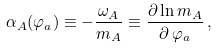Convert formula to latex. <formula><loc_0><loc_0><loc_500><loc_500>\alpha _ { A } ( \varphi _ { a } ) \equiv - \frac { \omega _ { A } } { m _ { A } } \equiv \frac { \partial \ln m _ { A } } { \partial \, \varphi _ { a } } \, ,</formula> 